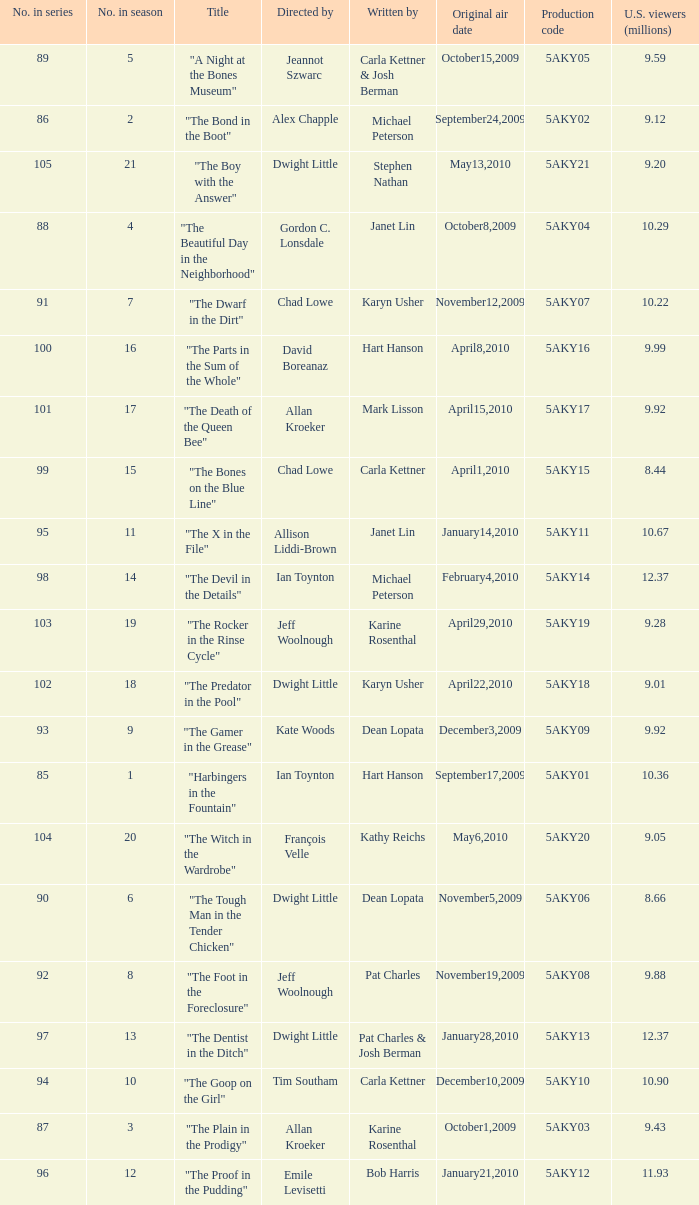Who was the writer of the episode with a production code of 5aky04? Janet Lin. 